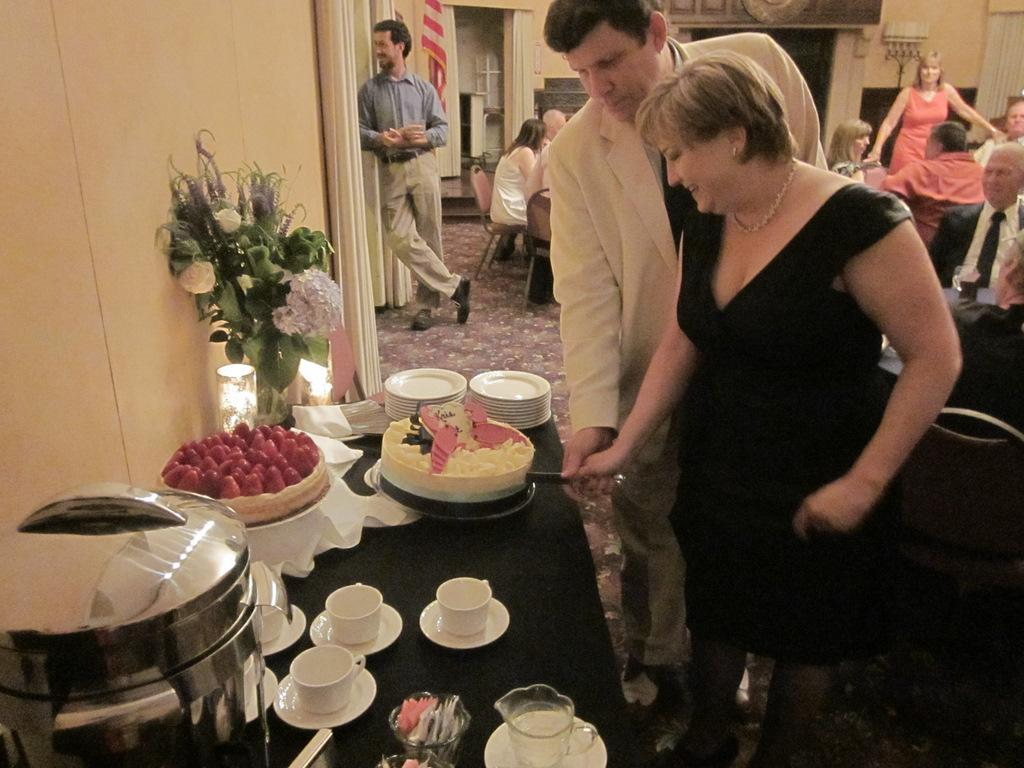What is present in the image that serves as a background or boundary? There is a wall in the image. What are the people in the image doing? The people are sitting on chairs in the image. What is on the table in the image? There is a cake, plates, a bouquet, cups, saucers, and bowls on the table. How many different types of tableware can be seen on the table? There are six different types of tableware on the table: plates, cups, saucers, and bowls. What type of plant is growing on the uncle's lip in the image? There is no uncle or plant growing on a lip present in the image. What type of plant is growing on the table in the image? There is no plant growing on the table in the image; it features a cake, plates, a bouquet, cups, saucers, and bowls. 